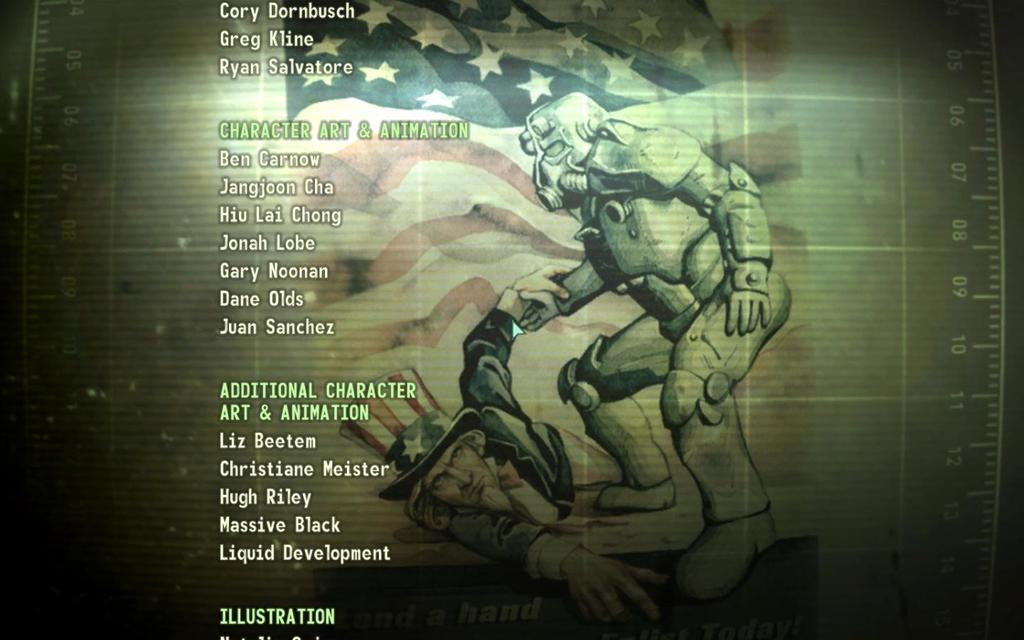Provide a one-sentence caption for the provided image. The credits screen is playing and shows that Ben Carnow worked on character art and animation. 